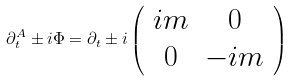<formula> <loc_0><loc_0><loc_500><loc_500>\partial _ { t } ^ { A } \pm i \Phi = \partial _ { t } \pm i \left ( \begin{array} { c c } i m & 0 \\ 0 & - i m \end{array} \right )</formula> 